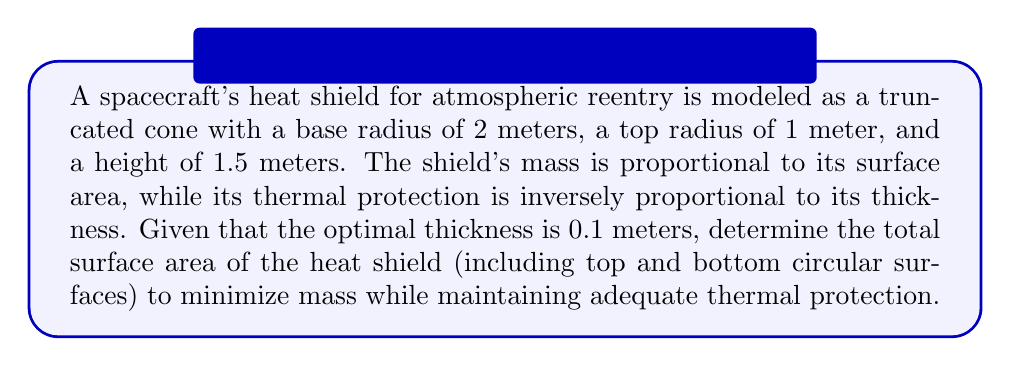Can you answer this question? To solve this problem, we need to calculate the surface area of a truncated cone, including its top and bottom circular surfaces. Let's break this down step-by-step:

1) First, let's define our variables:
   $r_1 = 2$ m (base radius)
   $r_2 = 1$ m (top radius)
   $h = 1.5$ m (height)

2) The surface area of a truncated cone consists of three parts:
   a) The area of the base circle
   b) The area of the top circle
   c) The lateral surface area

3) Area of the base circle:
   $A_1 = \pi r_1^2 = \pi (2)^2 = 4\pi$ m²

4) Area of the top circle:
   $A_2 = \pi r_2^2 = \pi (1)^2 = \pi$ m²

5) For the lateral surface area, we need to calculate the slant height $s$:
   $s = \sqrt{h^2 + (r_1 - r_2)^2}$
   $s = \sqrt{(1.5)^2 + (2 - 1)^2} = \sqrt{2.25 + 1} = \sqrt{3.25} \approx 1.803$ m

6) Now we can calculate the lateral surface area:
   $A_\text{lateral} = \pi(r_1 + r_2)s = \pi(2 + 1)(1.803) = 3\pi(1.803) \approx 16.988$ m²

7) The total surface area is the sum of all three parts:
   $A_\text{total} = A_1 + A_2 + A_\text{lateral}$
   $A_\text{total} = 4\pi + \pi + 3\pi(1.803)$
   $A_\text{total} = 5\pi + 3\pi(1.803)$
   $A_\text{total} \approx 15.708 + 16.988 = 32.696$ m²

This total surface area represents the optimal design that minimizes mass while maintaining adequate thermal protection, given the constraints of the problem.
Answer: The total surface area of the heat shield is approximately 32.696 m². 